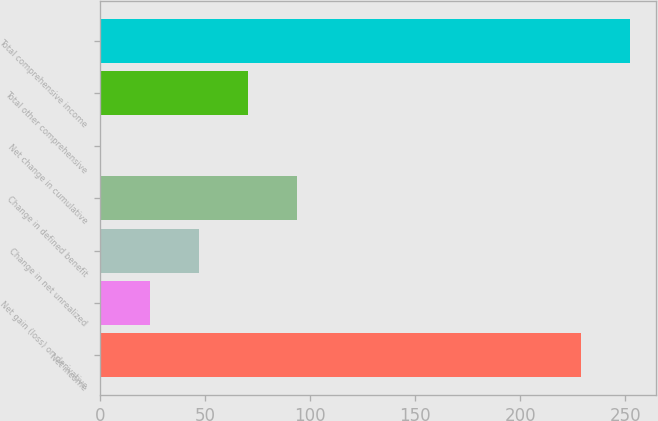<chart> <loc_0><loc_0><loc_500><loc_500><bar_chart><fcel>Net income<fcel>Net gain (loss) on derivative<fcel>Change in net unrealized<fcel>Change in defined benefit<fcel>Net change in cumulative<fcel>Total other comprehensive<fcel>Total comprehensive income<nl><fcel>228.8<fcel>23.48<fcel>46.86<fcel>93.62<fcel>0.1<fcel>70.24<fcel>252.18<nl></chart> 